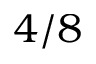<formula> <loc_0><loc_0><loc_500><loc_500>4 / 8</formula> 